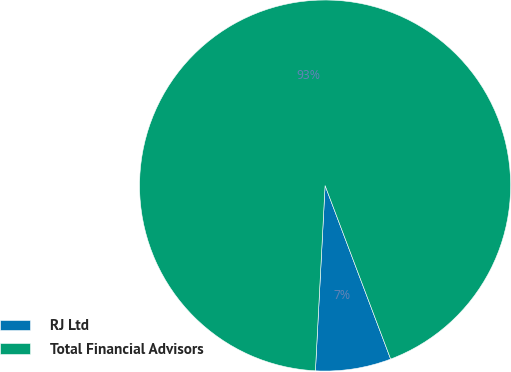Convert chart. <chart><loc_0><loc_0><loc_500><loc_500><pie_chart><fcel>RJ Ltd<fcel>Total Financial Advisors<nl><fcel>6.58%<fcel>93.42%<nl></chart> 